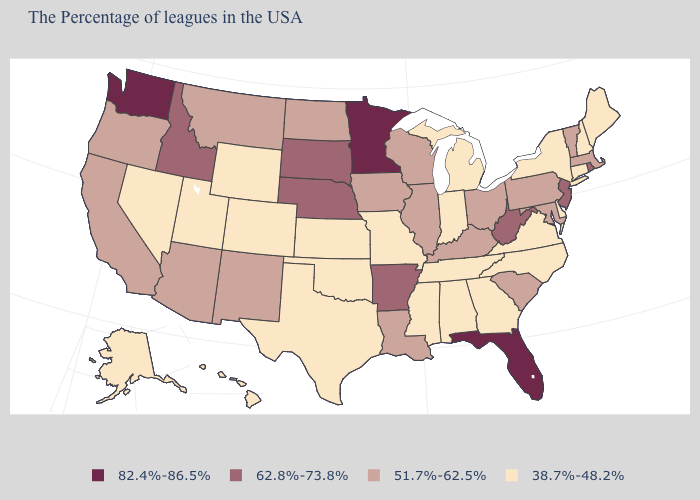Does the map have missing data?
Short answer required. No. Name the states that have a value in the range 51.7%-62.5%?
Quick response, please. Massachusetts, Vermont, Maryland, Pennsylvania, South Carolina, Ohio, Kentucky, Wisconsin, Illinois, Louisiana, Iowa, North Dakota, New Mexico, Montana, Arizona, California, Oregon. What is the value of Maryland?
Answer briefly. 51.7%-62.5%. Name the states that have a value in the range 38.7%-48.2%?
Keep it brief. Maine, New Hampshire, Connecticut, New York, Delaware, Virginia, North Carolina, Georgia, Michigan, Indiana, Alabama, Tennessee, Mississippi, Missouri, Kansas, Oklahoma, Texas, Wyoming, Colorado, Utah, Nevada, Alaska, Hawaii. What is the value of Oregon?
Short answer required. 51.7%-62.5%. Does Pennsylvania have the same value as New Hampshire?
Short answer required. No. Does the map have missing data?
Be succinct. No. Does Minnesota have a higher value than Washington?
Write a very short answer. No. What is the value of Massachusetts?
Give a very brief answer. 51.7%-62.5%. Name the states that have a value in the range 82.4%-86.5%?
Answer briefly. Florida, Minnesota, Washington. Name the states that have a value in the range 51.7%-62.5%?
Quick response, please. Massachusetts, Vermont, Maryland, Pennsylvania, South Carolina, Ohio, Kentucky, Wisconsin, Illinois, Louisiana, Iowa, North Dakota, New Mexico, Montana, Arizona, California, Oregon. What is the lowest value in the USA?
Short answer required. 38.7%-48.2%. Name the states that have a value in the range 51.7%-62.5%?
Concise answer only. Massachusetts, Vermont, Maryland, Pennsylvania, South Carolina, Ohio, Kentucky, Wisconsin, Illinois, Louisiana, Iowa, North Dakota, New Mexico, Montana, Arizona, California, Oregon. What is the value of Maine?
Keep it brief. 38.7%-48.2%. Does Washington have the highest value in the USA?
Answer briefly. Yes. 